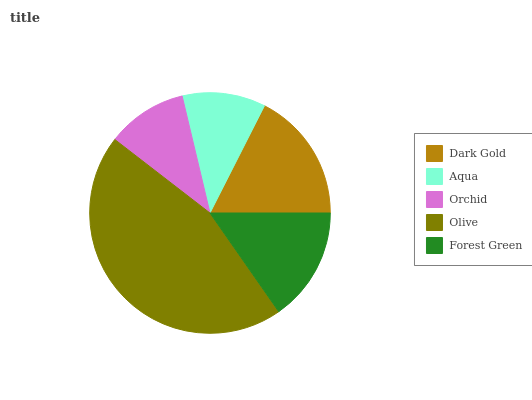Is Orchid the minimum?
Answer yes or no. Yes. Is Olive the maximum?
Answer yes or no. Yes. Is Aqua the minimum?
Answer yes or no. No. Is Aqua the maximum?
Answer yes or no. No. Is Dark Gold greater than Aqua?
Answer yes or no. Yes. Is Aqua less than Dark Gold?
Answer yes or no. Yes. Is Aqua greater than Dark Gold?
Answer yes or no. No. Is Dark Gold less than Aqua?
Answer yes or no. No. Is Forest Green the high median?
Answer yes or no. Yes. Is Forest Green the low median?
Answer yes or no. Yes. Is Olive the high median?
Answer yes or no. No. Is Aqua the low median?
Answer yes or no. No. 